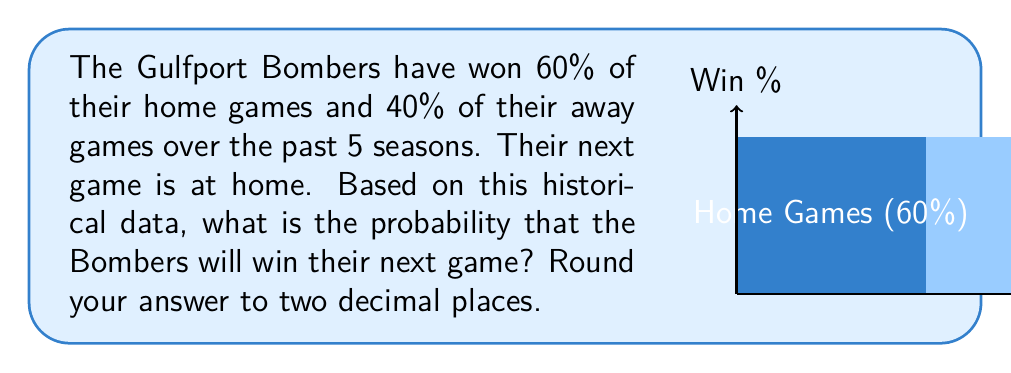Provide a solution to this math problem. Let's approach this step-by-step:

1) We are given two pieces of crucial information:
   - The Bombers win 60% of their home games
   - The next game is at home

2) Since the next game is at home, we only need to consider the home game statistics.

3) The probability of an event is often expressed as a decimal between 0 and 1. To convert a percentage to a probability, we divide by 100:

   $$P(\text{win at home}) = \frac{60}{100} = 0.60$$

4) This probability already matches our requirement of rounding to two decimal places, so no further calculation is needed.

5) Therefore, based on the historical data provided, the probability that the Bombers will win their next game (which is at home) is 0.60 or 60%.
Answer: 0.60 